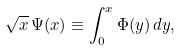Convert formula to latex. <formula><loc_0><loc_0><loc_500><loc_500>\sqrt { x } \, \Psi ( x ) \equiv \int _ { 0 } ^ { x } \Phi ( y ) \, d y ,</formula> 